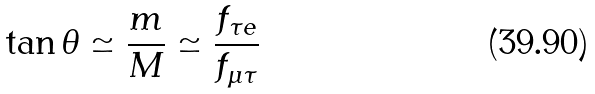<formula> <loc_0><loc_0><loc_500><loc_500>\tan \theta \simeq \frac { m } { M } \simeq \frac { f _ { \tau e } } { f _ { \mu \tau } }</formula> 